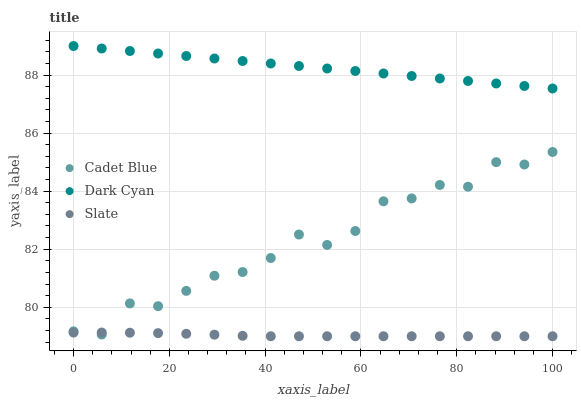Does Slate have the minimum area under the curve?
Answer yes or no. Yes. Does Dark Cyan have the maximum area under the curve?
Answer yes or no. Yes. Does Cadet Blue have the minimum area under the curve?
Answer yes or no. No. Does Cadet Blue have the maximum area under the curve?
Answer yes or no. No. Is Dark Cyan the smoothest?
Answer yes or no. Yes. Is Cadet Blue the roughest?
Answer yes or no. Yes. Is Slate the smoothest?
Answer yes or no. No. Is Slate the roughest?
Answer yes or no. No. Does Slate have the lowest value?
Answer yes or no. Yes. Does Cadet Blue have the lowest value?
Answer yes or no. No. Does Dark Cyan have the highest value?
Answer yes or no. Yes. Does Cadet Blue have the highest value?
Answer yes or no. No. Is Cadet Blue less than Dark Cyan?
Answer yes or no. Yes. Is Dark Cyan greater than Cadet Blue?
Answer yes or no. Yes. Does Cadet Blue intersect Slate?
Answer yes or no. Yes. Is Cadet Blue less than Slate?
Answer yes or no. No. Is Cadet Blue greater than Slate?
Answer yes or no. No. Does Cadet Blue intersect Dark Cyan?
Answer yes or no. No. 